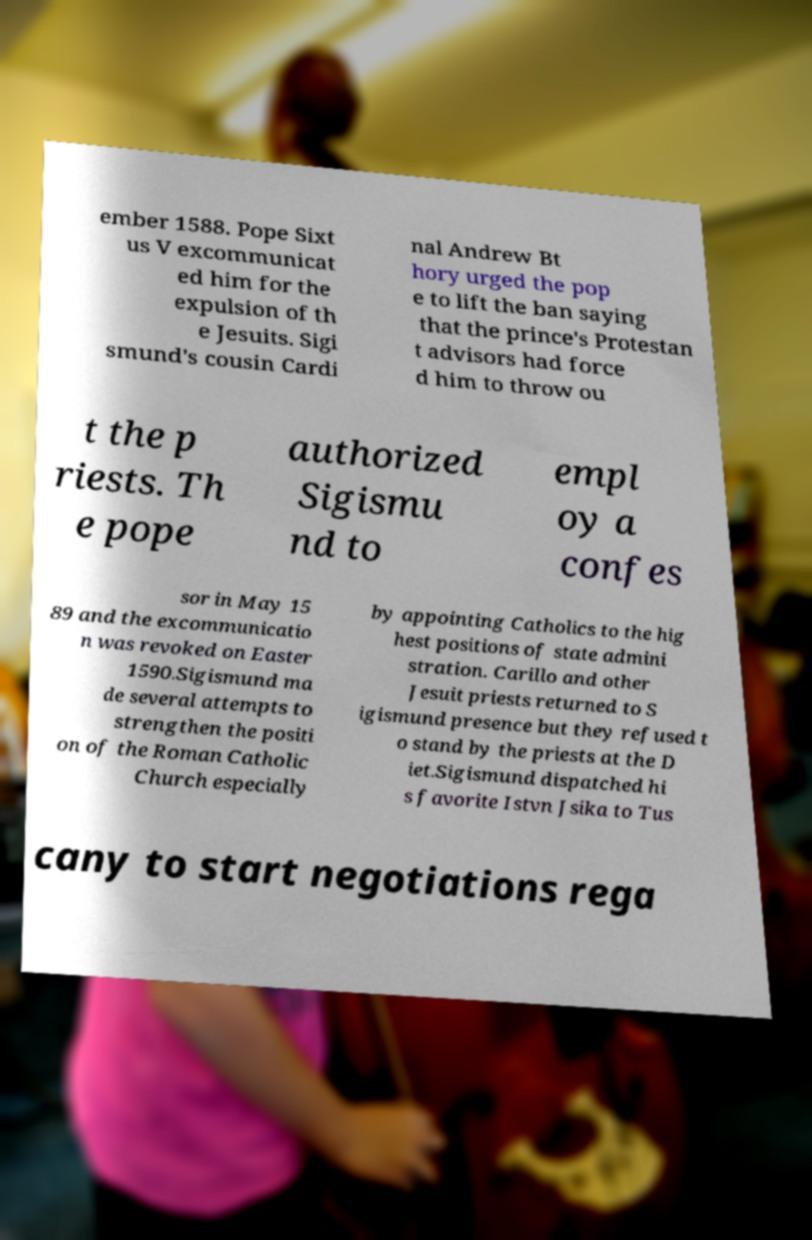What messages or text are displayed in this image? I need them in a readable, typed format. ember 1588. Pope Sixt us V excommunicat ed him for the expulsion of th e Jesuits. Sigi smund's cousin Cardi nal Andrew Bt hory urged the pop e to lift the ban saying that the prince's Protestan t advisors had force d him to throw ou t the p riests. Th e pope authorized Sigismu nd to empl oy a confes sor in May 15 89 and the excommunicatio n was revoked on Easter 1590.Sigismund ma de several attempts to strengthen the positi on of the Roman Catholic Church especially by appointing Catholics to the hig hest positions of state admini stration. Carillo and other Jesuit priests returned to S igismund presence but they refused t o stand by the priests at the D iet.Sigismund dispatched hi s favorite Istvn Jsika to Tus cany to start negotiations rega 